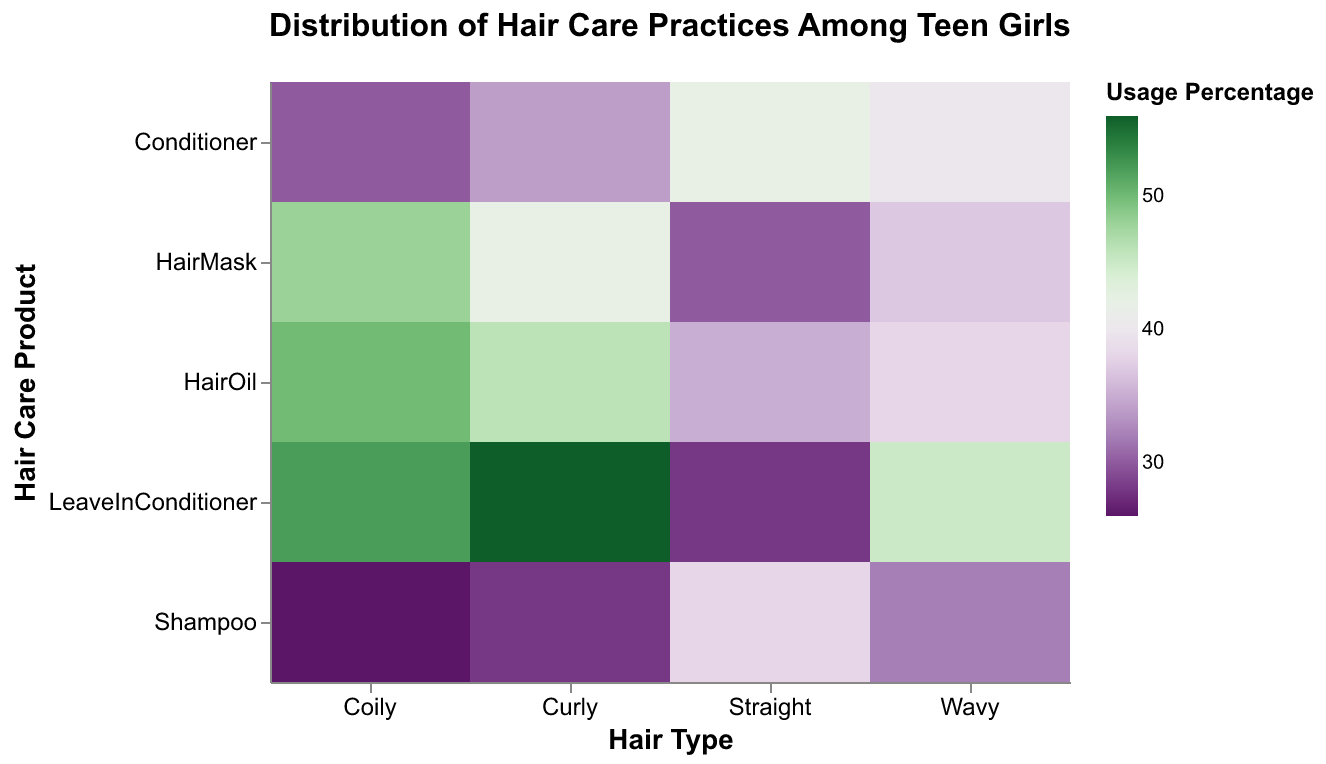What is the title of the figure? The title is located at the top of the figure. It reads "Distribution of Hair Care Practices Among Teen Girls".
Answer: Distribution of Hair Care Practices Among Teen Girls Which hair type uses Leave-In Conditioner the most? By looking at the color intensity for Leave-In Conditioner across different hair types, the darkest shade indicates the highest usage percentage. Curly hair has the highest usage for Leave-In Conditioner.
Answer: Curly Which hair care product has the highest usage percentage for girls with Coily hair? Check across Coily hair for the darkest shade, which appears in the Hair Oil column. Coily hair has the highest usage percentage for Hair Oil.
Answer: Hair Oil What is the least used product for girls with Straight hair? Look for the lightest shade in the Straight hair row, which indicates the lowest percentage. The lightest shade is observed for Leave-In Conditioner.
Answer: Leave-In Conditioner Compare the usage percentage of Hair Mask between Wavy and Curly hair. Which one is higher? Locate Hair Mask for Wavy and Curly hair and compare the shades. The darker shade indicates a higher usage percentage, which is higher for Curly hair.
Answer: Curly What is the median usage percentage of hair products for girls with Wavy hair? The usage percentages are 32, 40, 37, 45, and 38. Arranging them in ascending order: 32, 37, 38, 40, 45. The median is the middle value, which is 38.
Answer: 38 Which hair care product is used equally by girls with Curly hair and Coily hair? Identify any product with the same color shade for both Curly and Coily hair. Conditioner has the same shade for both hair types.
Answer: Conditioner Which hair type has the most varied distribution of product usage, and what might this indicate? By examining the range of shades for each hair type, Coily hair shows the most variation from the darkest to the lightest shades. This indicates varied usage preferences.
Answer: Coily Is there a trend in usage percentages of Leave-In Conditioner across different hair types? The shades for Leave-In Conditioner get progressively darker from Straight to Coily hair. This indicates an increasing trend in usage percentage from Straight to Coily.
Answer: Increasing trend 